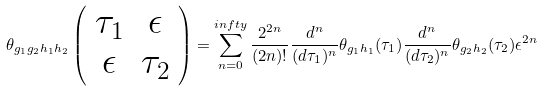Convert formula to latex. <formula><loc_0><loc_0><loc_500><loc_500>\theta _ { g _ { 1 } g _ { 2 } h _ { 1 } h _ { 2 } } \left ( \begin{array} { c c } \tau _ { 1 } & \epsilon \\ \epsilon & \tau _ { 2 } \end{array} \right ) = \sum _ { n = 0 } ^ { i n f t y } \frac { 2 ^ { 2 n } } { ( 2 n ) ! } \frac { d ^ { n } } { ( d \tau _ { 1 } ) ^ { n } } \theta _ { g _ { 1 } h _ { 1 } } ( \tau _ { 1 } ) \frac { d ^ { n } } { ( d \tau _ { 2 } ) ^ { n } } \theta _ { g _ { 2 } h _ { 2 } } ( \tau _ { 2 } ) \epsilon ^ { 2 n }</formula> 